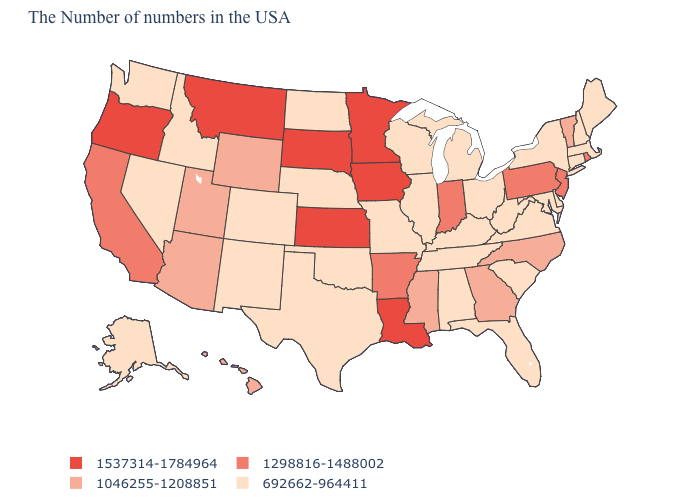Does California have the lowest value in the USA?
Answer briefly. No. What is the value of Ohio?
Concise answer only. 692662-964411. Which states hav the highest value in the South?
Be succinct. Louisiana. What is the lowest value in the MidWest?
Quick response, please. 692662-964411. What is the lowest value in states that border Louisiana?
Keep it brief. 692662-964411. Does New York have the lowest value in the USA?
Be succinct. Yes. Name the states that have a value in the range 1537314-1784964?
Short answer required. Louisiana, Minnesota, Iowa, Kansas, South Dakota, Montana, Oregon. Does Georgia have the same value as Hawaii?
Concise answer only. Yes. Among the states that border New Hampshire , does Vermont have the lowest value?
Write a very short answer. No. Name the states that have a value in the range 1046255-1208851?
Answer briefly. Vermont, North Carolina, Georgia, Mississippi, Wyoming, Utah, Arizona, Hawaii. Name the states that have a value in the range 692662-964411?
Write a very short answer. Maine, Massachusetts, New Hampshire, Connecticut, New York, Delaware, Maryland, Virginia, South Carolina, West Virginia, Ohio, Florida, Michigan, Kentucky, Alabama, Tennessee, Wisconsin, Illinois, Missouri, Nebraska, Oklahoma, Texas, North Dakota, Colorado, New Mexico, Idaho, Nevada, Washington, Alaska. What is the value of Iowa?
Be succinct. 1537314-1784964. Does South Dakota have the highest value in the MidWest?
Keep it brief. Yes. Which states have the lowest value in the USA?
Write a very short answer. Maine, Massachusetts, New Hampshire, Connecticut, New York, Delaware, Maryland, Virginia, South Carolina, West Virginia, Ohio, Florida, Michigan, Kentucky, Alabama, Tennessee, Wisconsin, Illinois, Missouri, Nebraska, Oklahoma, Texas, North Dakota, Colorado, New Mexico, Idaho, Nevada, Washington, Alaska. 